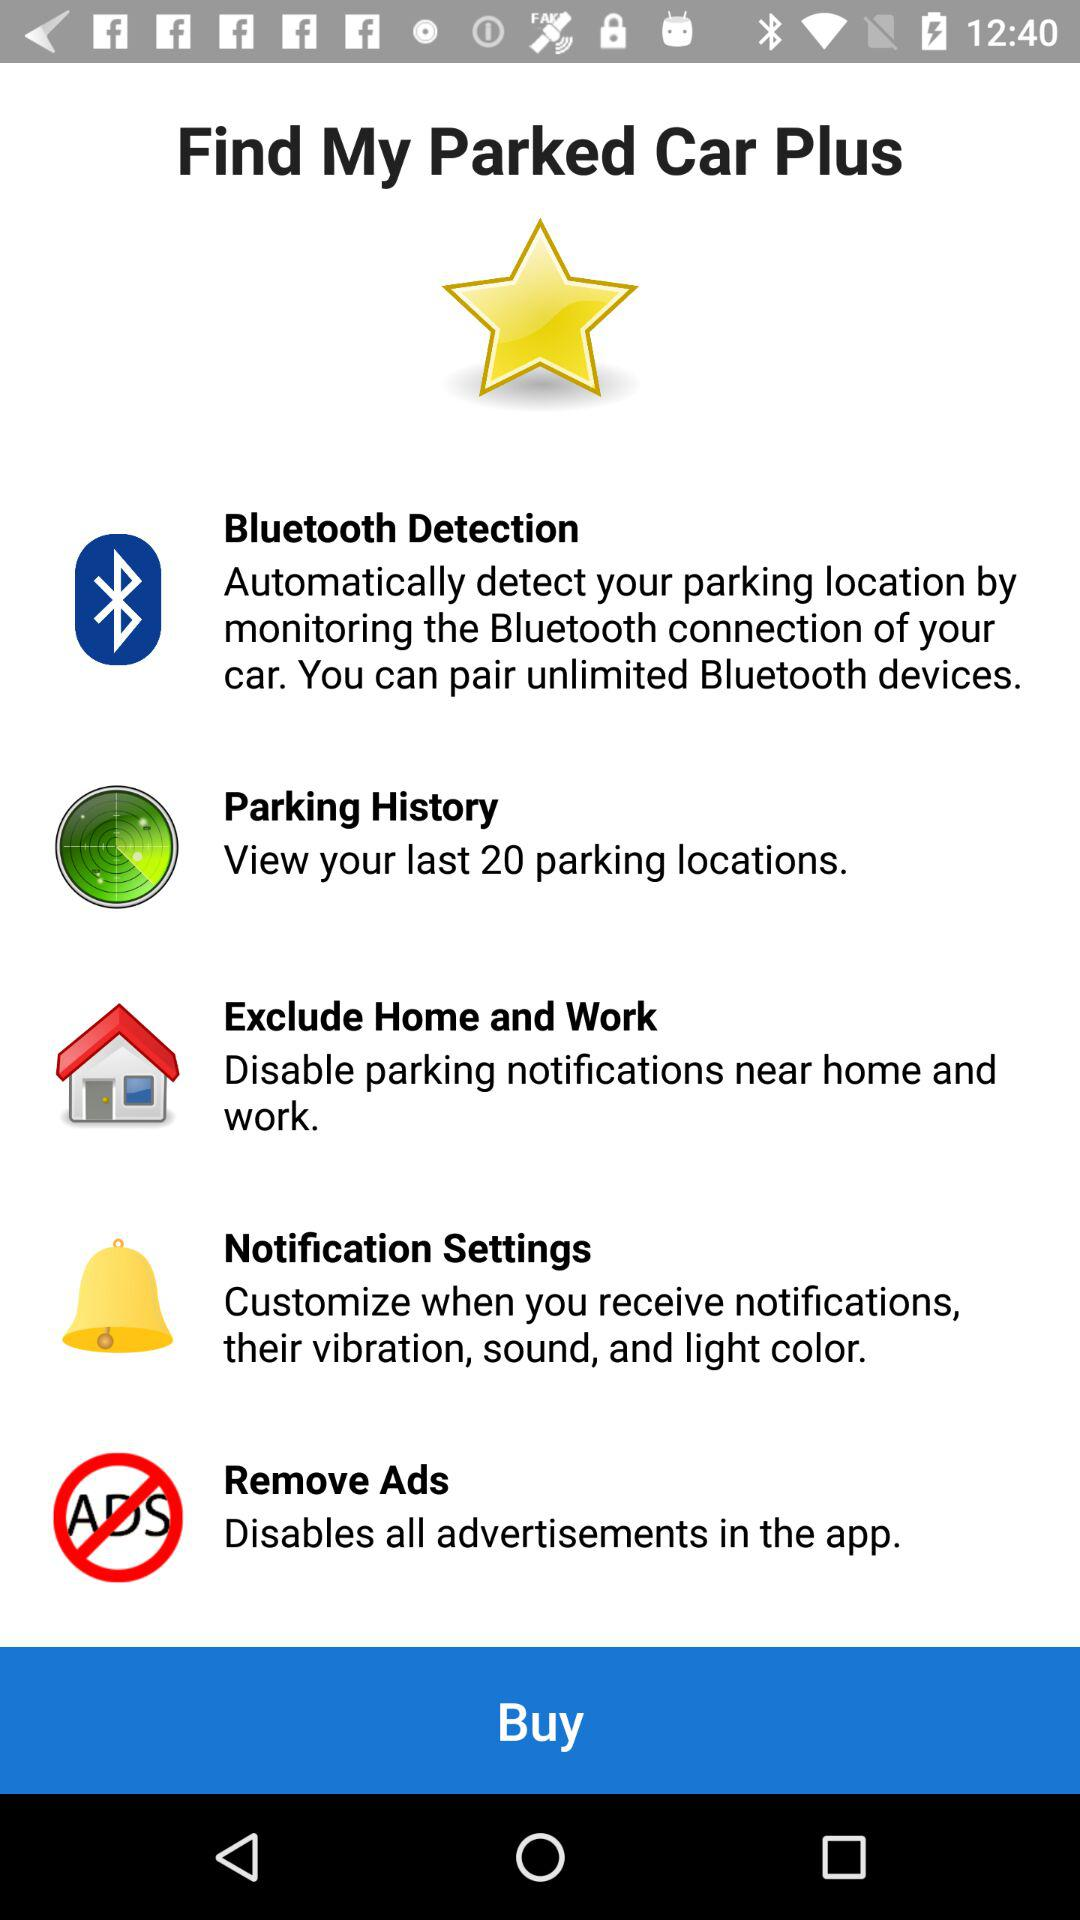How much does "Find My Parked Car Plus" cost?
When the provided information is insufficient, respond with <no answer>. <no answer> 